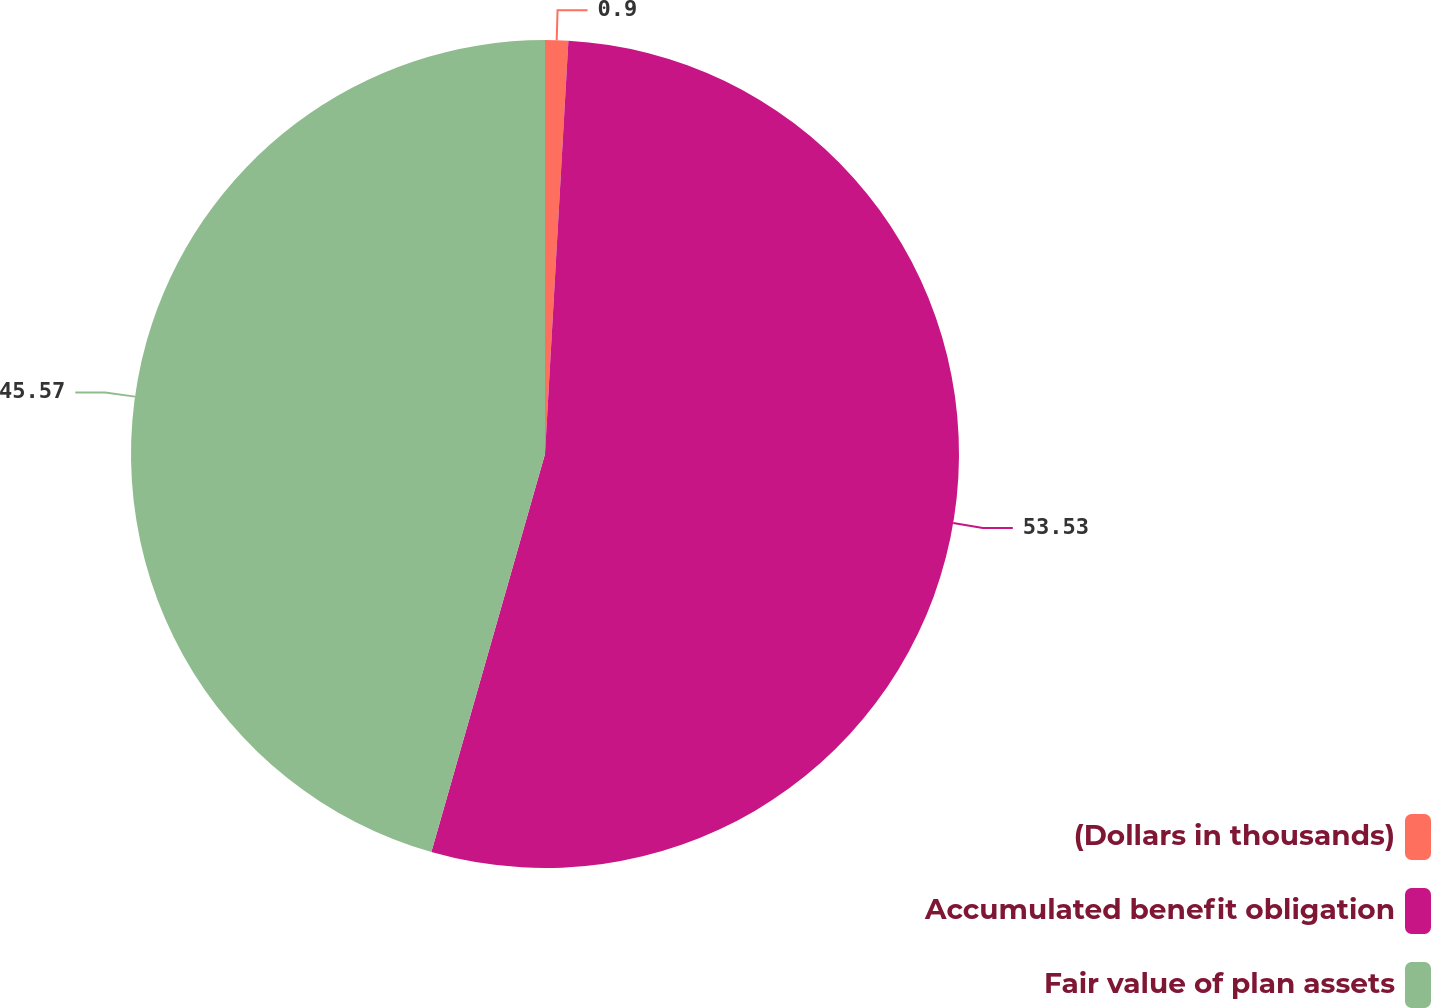Convert chart to OTSL. <chart><loc_0><loc_0><loc_500><loc_500><pie_chart><fcel>(Dollars in thousands)<fcel>Accumulated benefit obligation<fcel>Fair value of plan assets<nl><fcel>0.9%<fcel>53.52%<fcel>45.57%<nl></chart> 